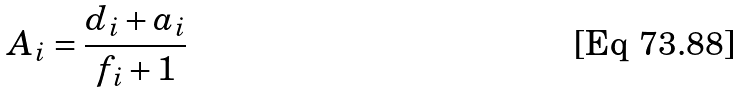Convert formula to latex. <formula><loc_0><loc_0><loc_500><loc_500>A _ { i } = \frac { d _ { i } + a _ { i } } { f _ { i } + 1 }</formula> 